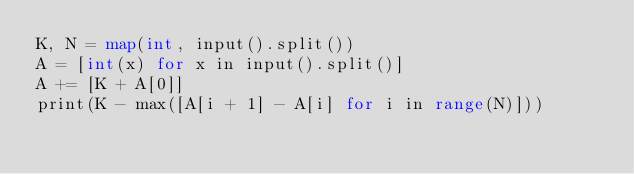Convert code to text. <code><loc_0><loc_0><loc_500><loc_500><_Go_>K, N = map(int, input().split())
A = [int(x) for x in input().split()]
A += [K + A[0]]
print(K - max([A[i + 1] - A[i] for i in range(N)]))</code> 